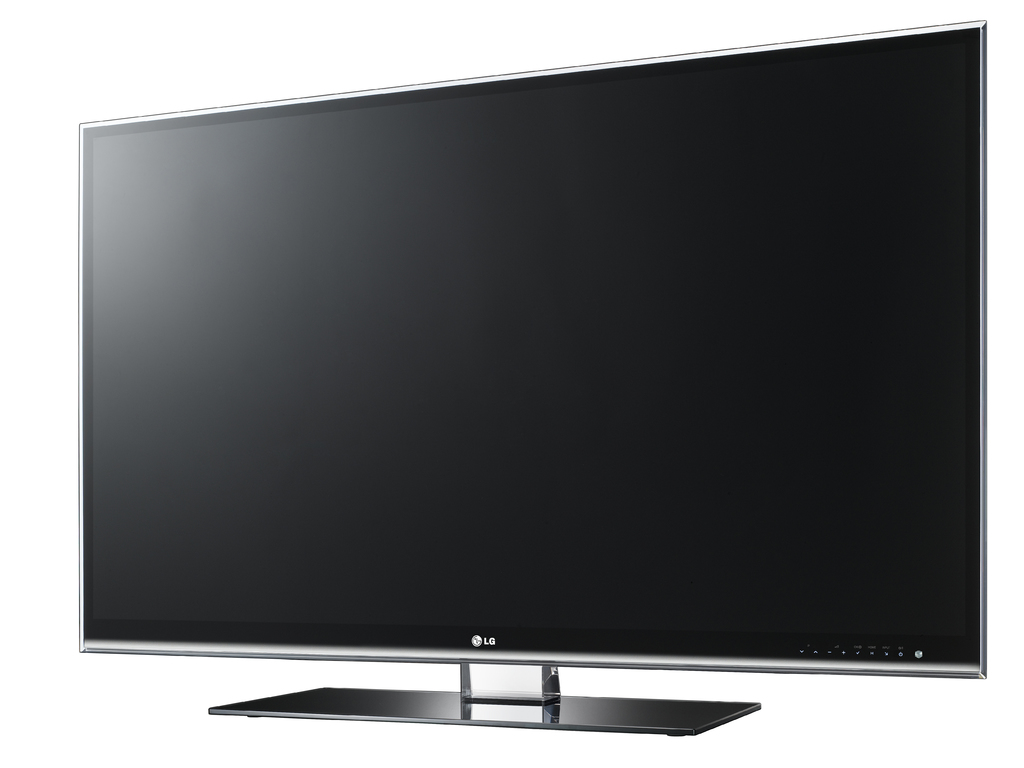How would this TV fit into a modern smart home environment? This LG TV, with its sophisticated connectivity features, can easily integrate into a smart home environment, allowing for voice control through AI assistants, seamless streaming from devices, and customization of display settings via mobile apps. Could it be connected to other devices? Absolutely, it can connect to various devices via HDMI, USB ports, and Bluetooth for a complete and versatile home entertainment system, possibly even syncing with sound bars or external speakers for an enhanced audio experience. 